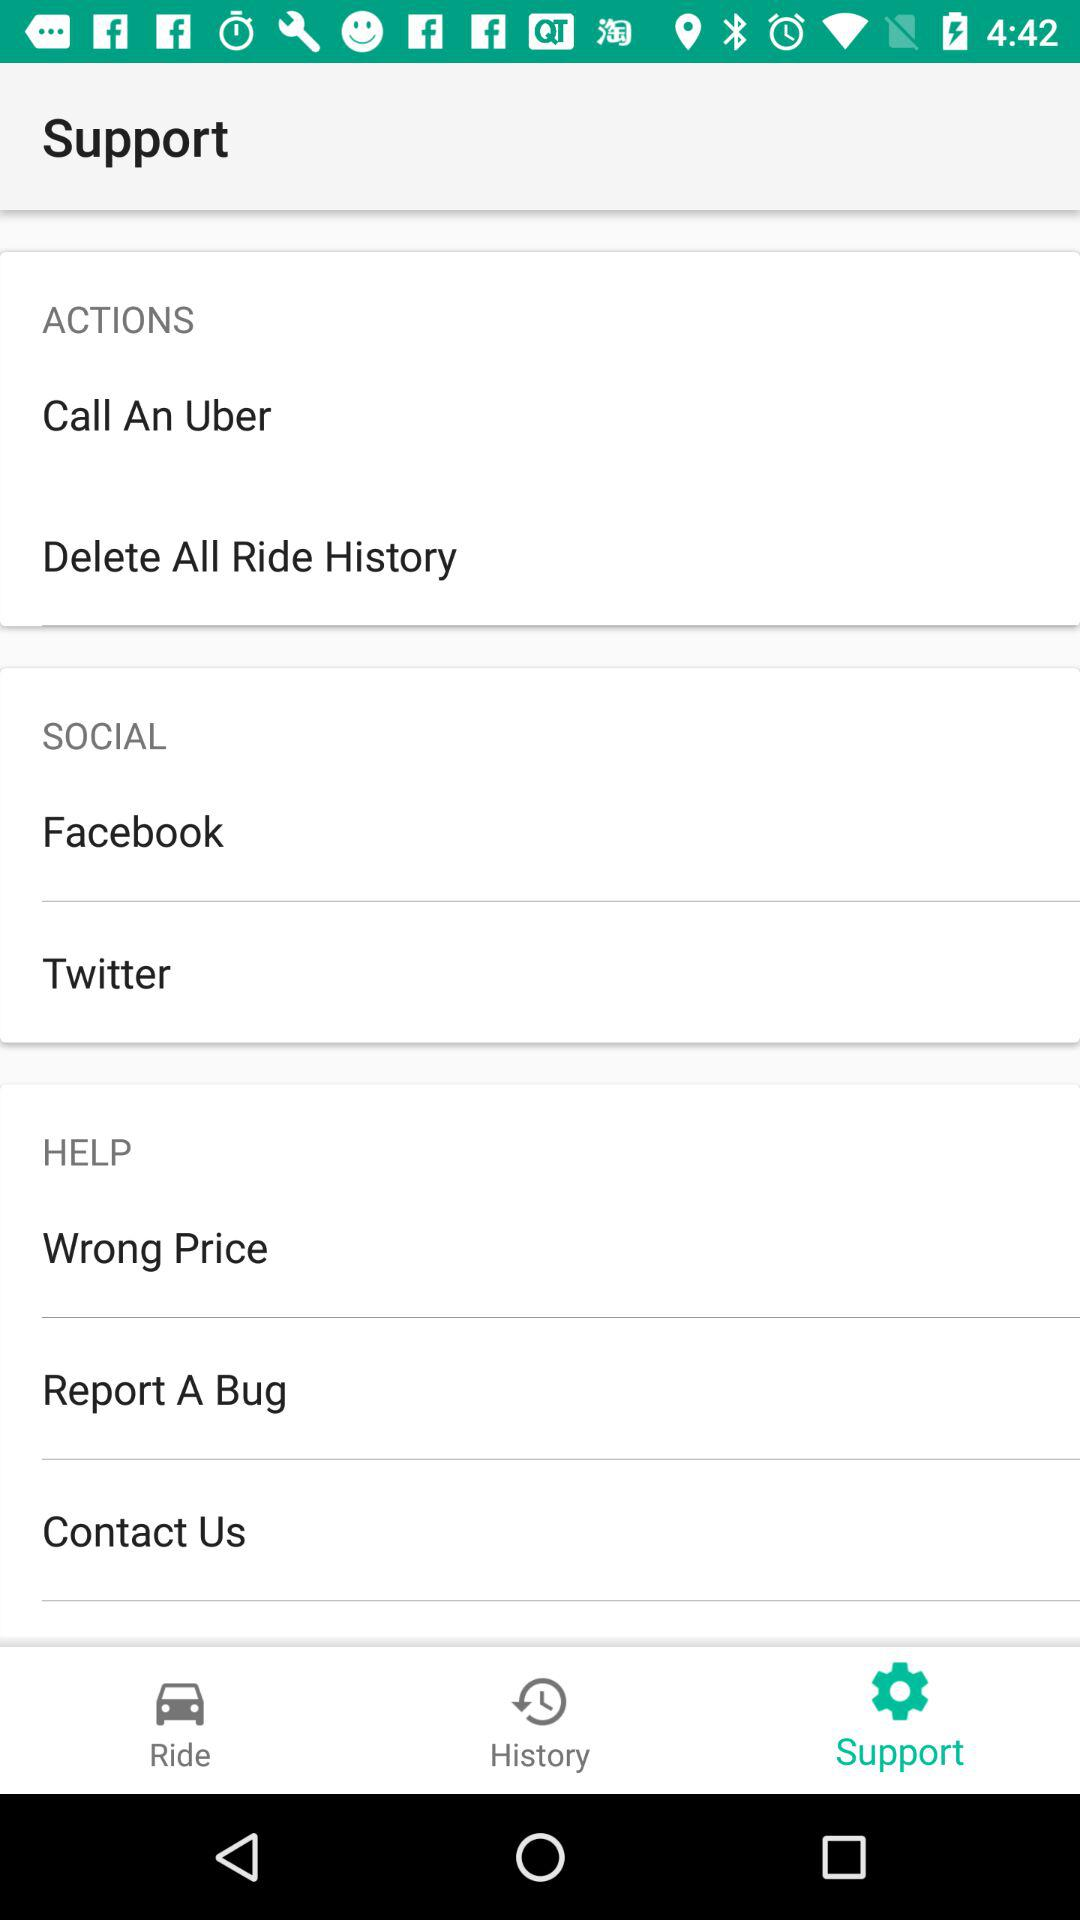How many social media options are there?
Answer the question using a single word or phrase. 2 